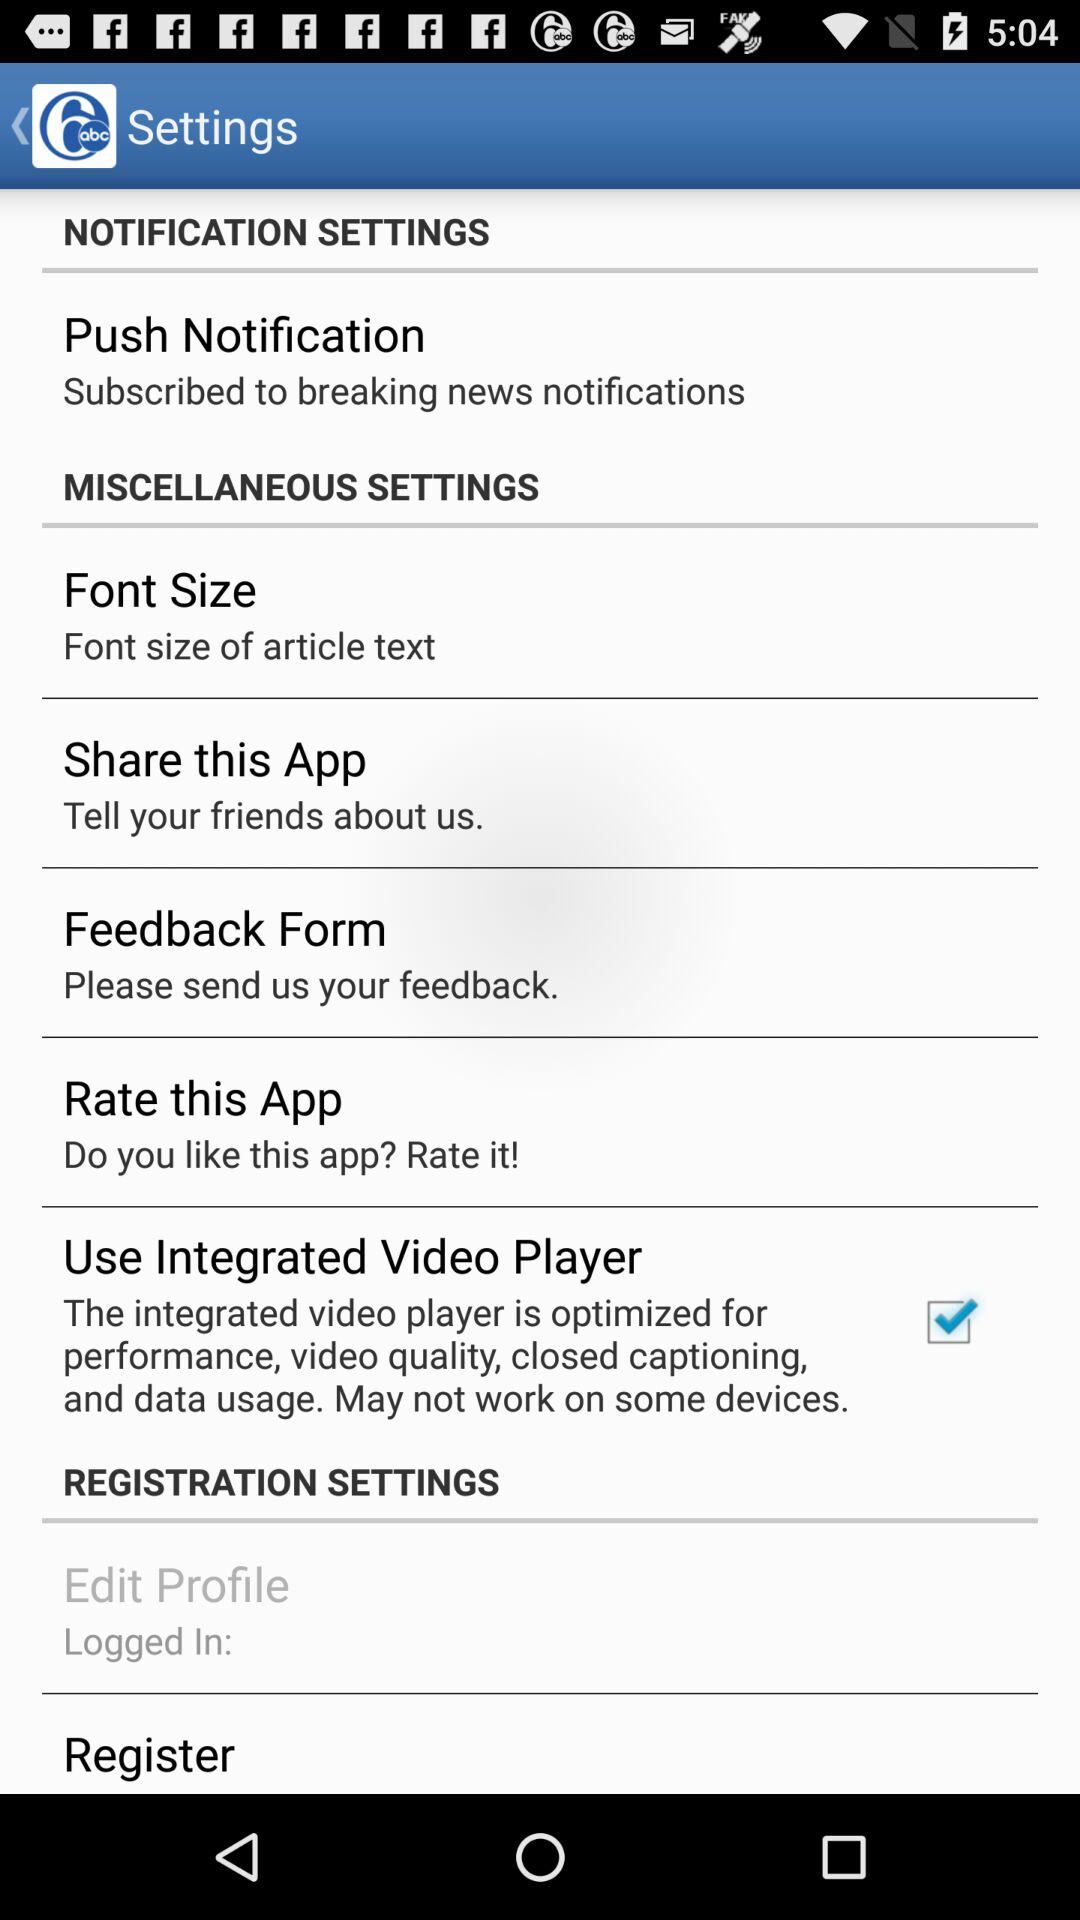What is the status of Push Notifications?
When the provided information is insufficient, respond with <no answer>. <no answer> 